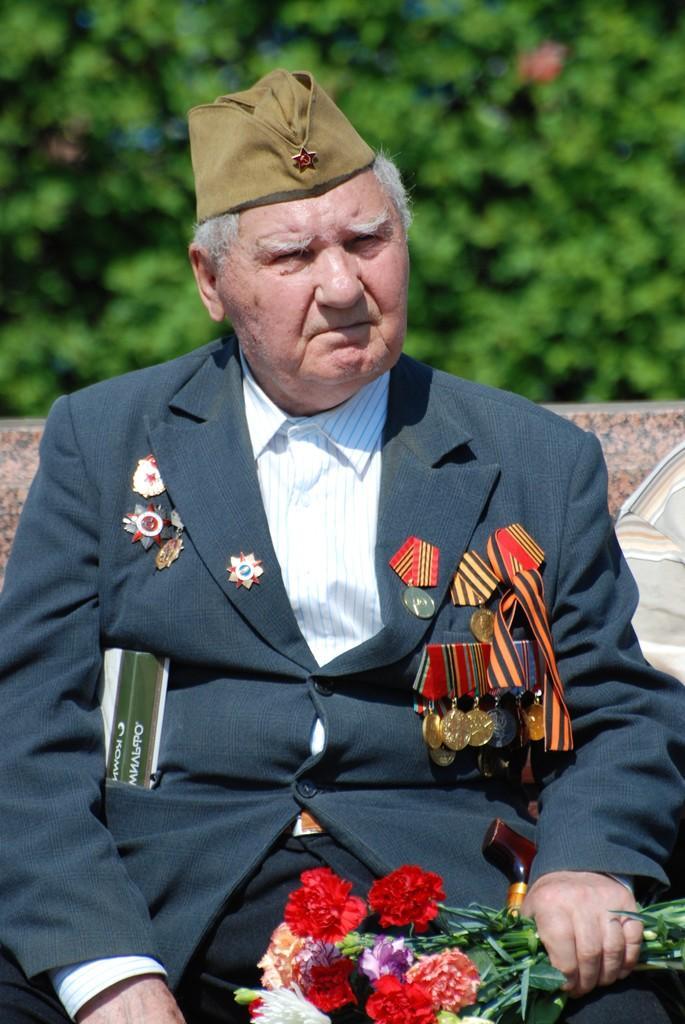Could you give a brief overview of what you see in this image? A man is sitting he wore a coat, shirt and a cap. There are bouquet of flowers in his hand. Behind him there are trees. 